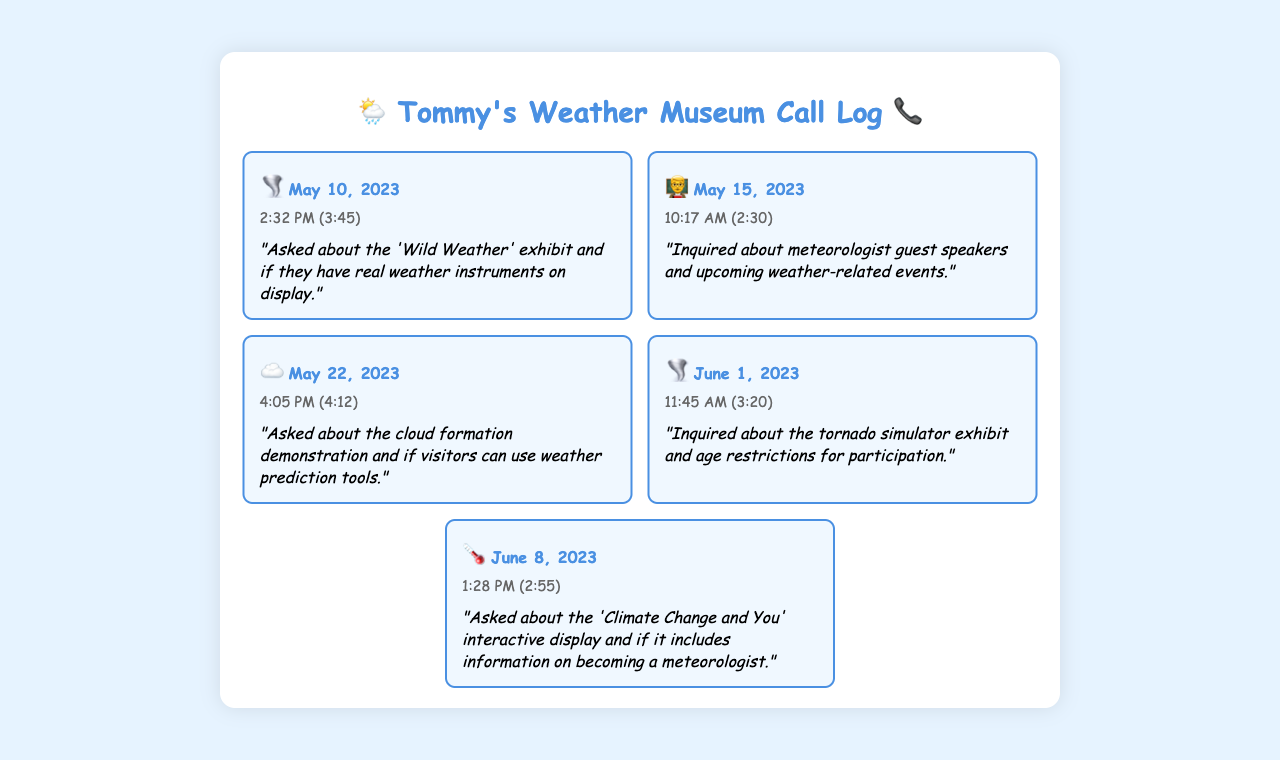What date was the call about the 'Wild Weather' exhibit? The call about the 'Wild Weather' exhibit was made on May 10, 2023.
Answer: May 10, 2023 What time was the call regarding meteorologist guest speakers? The call regarding meteorologist guest speakers was made at 10:17 AM.
Answer: 10:17 AM What is the duration of the call that asked about cloud formation? The duration of the call that asked about cloud formation was 4 minutes and 12 seconds.
Answer: 4:12 Which exhibit was mentioned in the call on June 1, 2023? The exhibit mentioned in the call on June 1, 2023, was the tornado simulator.
Answer: tornado simulator What was the common subject of the calls? The common subject of the calls was inquiries about meteorology exhibits.
Answer: inquiries about meteorology exhibits How many calls were made in total? There were a total of five calls made as evidenced by the list in the document.
Answer: five What specific information did the caller inquire about on June 8, 2023? The caller inquired about the 'Climate Change and You' interactive display and meteorology information.
Answer: 'Climate Change and You' interactive display What did callers often ask about regarding exhibits? Callers often asked if the exhibits included real weather instruments.
Answer: real weather instruments On which date did Tommy inquire about the tornado simulator? Tommy inquired about the tornado simulator on June 1, 2023.
Answer: June 1, 2023 